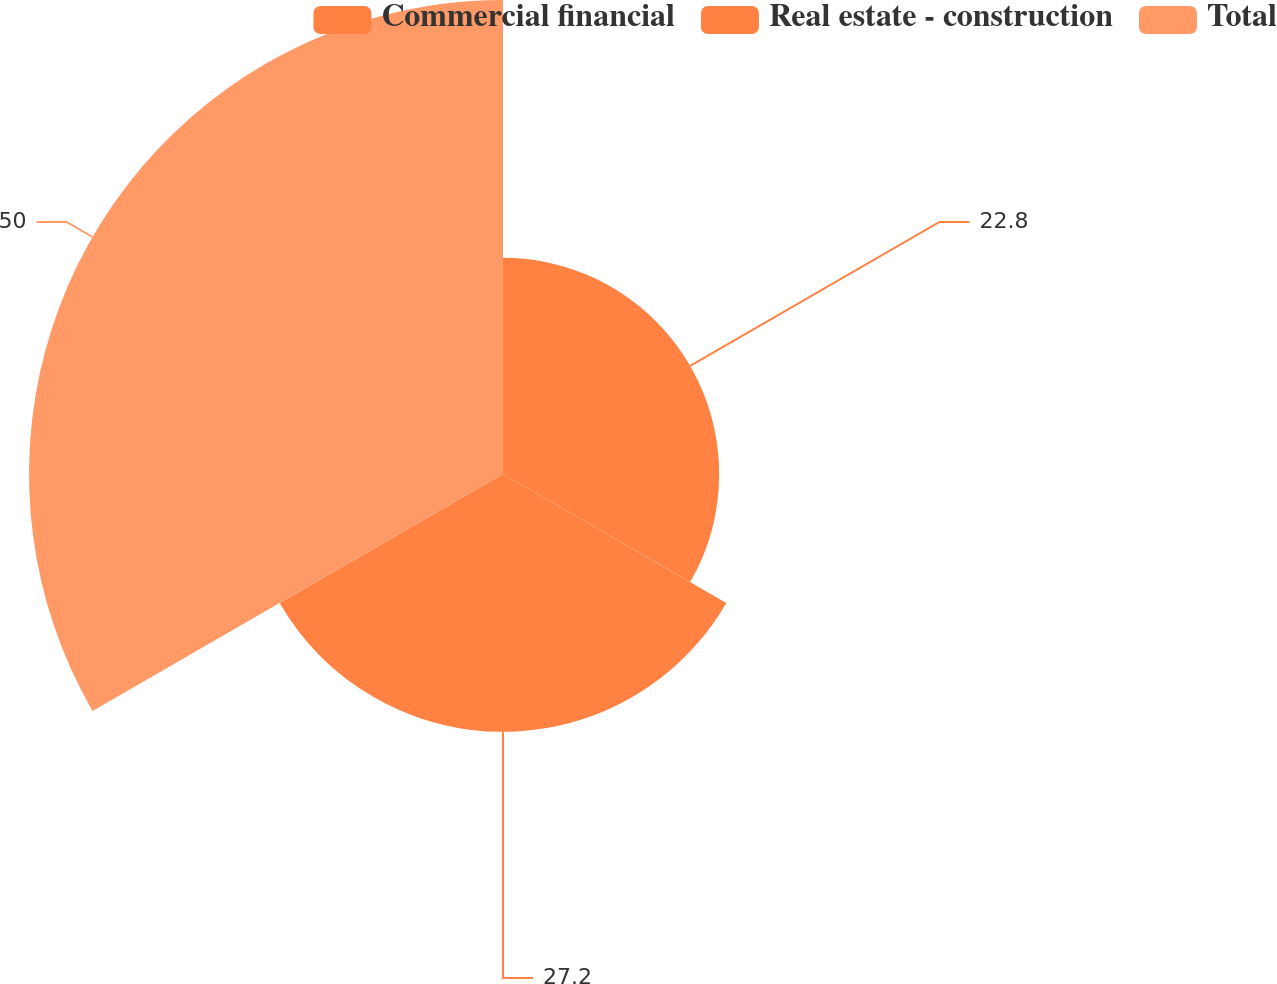<chart> <loc_0><loc_0><loc_500><loc_500><pie_chart><fcel>Commercial financial<fcel>Real estate - construction<fcel>Total<nl><fcel>22.8%<fcel>27.2%<fcel>50.0%<nl></chart> 